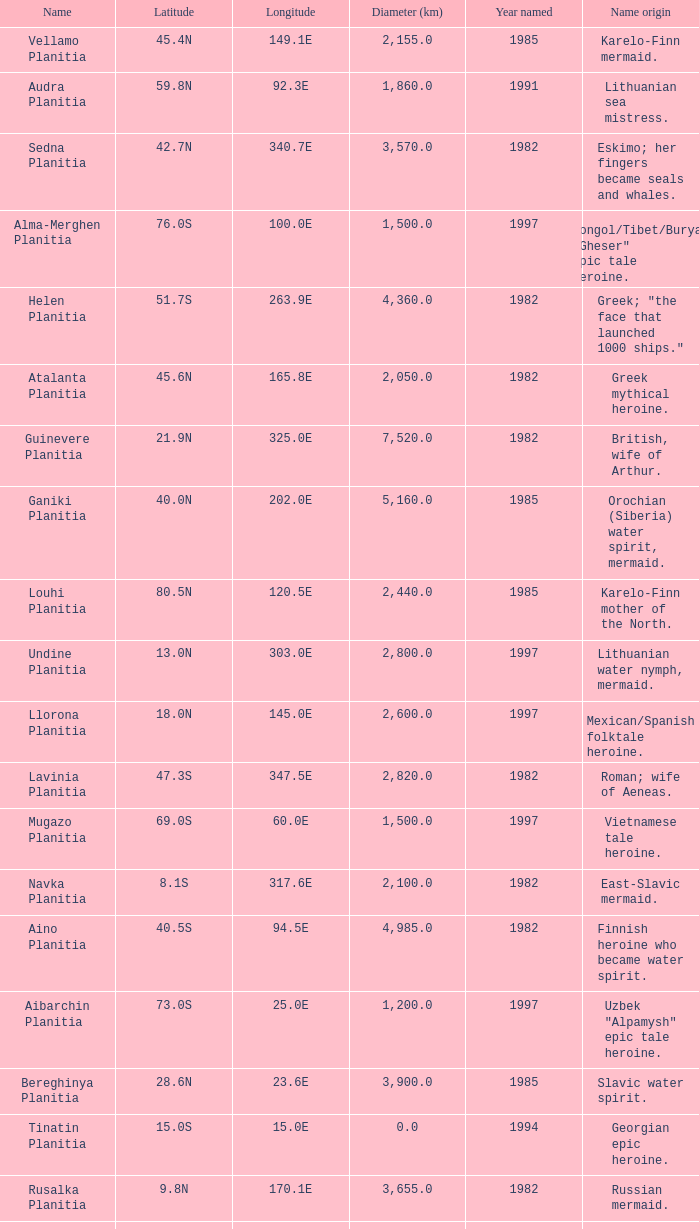What's the name origin of feature of diameter (km) 2,155.0 Karelo-Finn mermaid. 